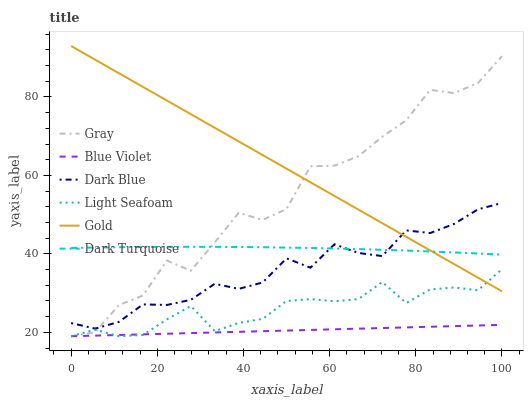Does Blue Violet have the minimum area under the curve?
Answer yes or no. Yes. Does Gold have the maximum area under the curve?
Answer yes or no. Yes. Does Dark Turquoise have the minimum area under the curve?
Answer yes or no. No. Does Dark Turquoise have the maximum area under the curve?
Answer yes or no. No. Is Blue Violet the smoothest?
Answer yes or no. Yes. Is Gray the roughest?
Answer yes or no. Yes. Is Gold the smoothest?
Answer yes or no. No. Is Gold the roughest?
Answer yes or no. No. Does Gray have the lowest value?
Answer yes or no. Yes. Does Gold have the lowest value?
Answer yes or no. No. Does Gold have the highest value?
Answer yes or no. Yes. Does Dark Turquoise have the highest value?
Answer yes or no. No. Is Blue Violet less than Gold?
Answer yes or no. Yes. Is Dark Blue greater than Blue Violet?
Answer yes or no. Yes. Does Gold intersect Dark Turquoise?
Answer yes or no. Yes. Is Gold less than Dark Turquoise?
Answer yes or no. No. Is Gold greater than Dark Turquoise?
Answer yes or no. No. Does Blue Violet intersect Gold?
Answer yes or no. No. 